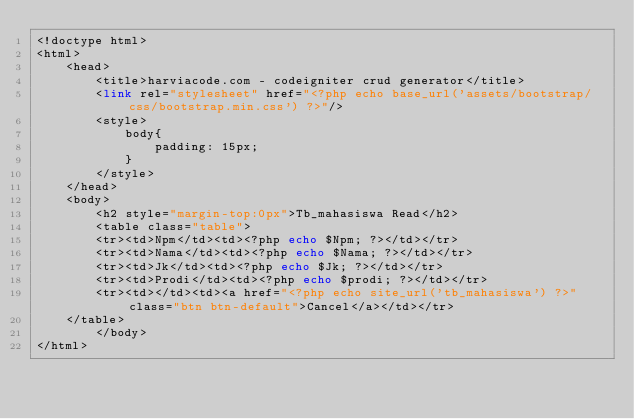<code> <loc_0><loc_0><loc_500><loc_500><_PHP_><!doctype html>
<html>
    <head>
        <title>harviacode.com - codeigniter crud generator</title>
        <link rel="stylesheet" href="<?php echo base_url('assets/bootstrap/css/bootstrap.min.css') ?>"/>
        <style>
            body{
                padding: 15px;
            }
        </style>
    </head>
    <body>
        <h2 style="margin-top:0px">Tb_mahasiswa Read</h2>
        <table class="table">
	    <tr><td>Npm</td><td><?php echo $Npm; ?></td></tr>
	    <tr><td>Nama</td><td><?php echo $Nama; ?></td></tr>
	    <tr><td>Jk</td><td><?php echo $Jk; ?></td></tr>
	    <tr><td>Prodi</td><td><?php echo $prodi; ?></td></tr>
	    <tr><td></td><td><a href="<?php echo site_url('tb_mahasiswa') ?>" class="btn btn-default">Cancel</a></td></tr>
	</table>
        </body>
</html></code> 